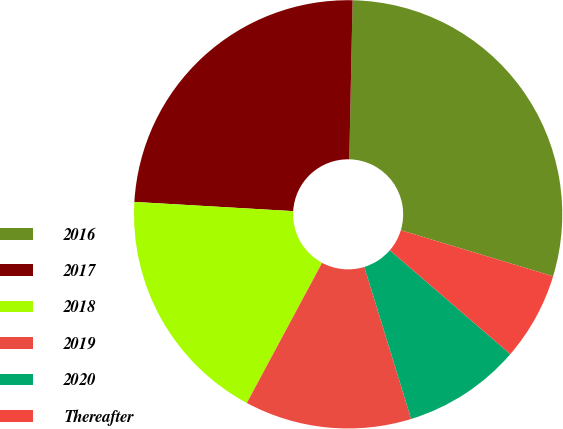Convert chart. <chart><loc_0><loc_0><loc_500><loc_500><pie_chart><fcel>2016<fcel>2017<fcel>2018<fcel>2019<fcel>2020<fcel>Thereafter<nl><fcel>29.34%<fcel>24.41%<fcel>18.08%<fcel>12.6%<fcel>8.92%<fcel>6.65%<nl></chart> 